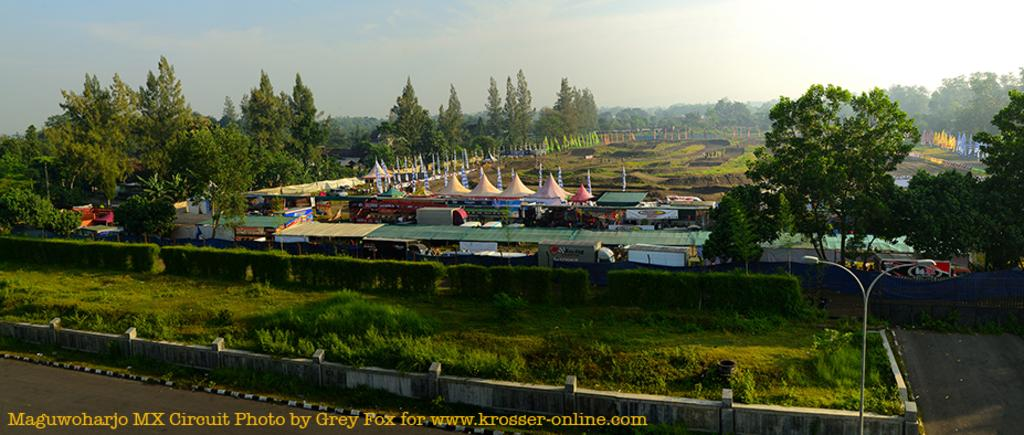What type of vegetation can be seen in the image? There are trees in the image. What is the color of the trees? The trees are green. What structures are present in the image? There are stalls and tents in the image. What is the color of the sky in the background? The sky in the background is blue and white. Can you see any yokes being used by the trees in the image? There are no yokes present in the image, as yokes are typically used for animals and not trees. How many toes are visible on the trees in the image? Trees do not have toes, so this question cannot be answered. 